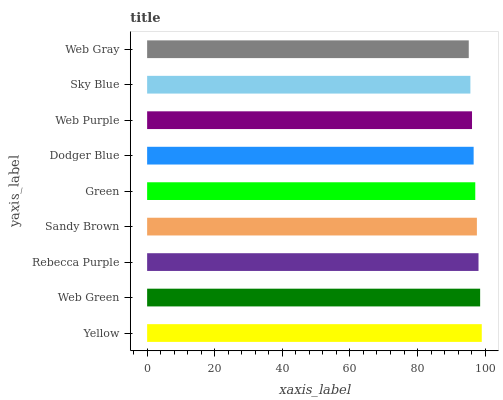Is Web Gray the minimum?
Answer yes or no. Yes. Is Yellow the maximum?
Answer yes or no. Yes. Is Web Green the minimum?
Answer yes or no. No. Is Web Green the maximum?
Answer yes or no. No. Is Yellow greater than Web Green?
Answer yes or no. Yes. Is Web Green less than Yellow?
Answer yes or no. Yes. Is Web Green greater than Yellow?
Answer yes or no. No. Is Yellow less than Web Green?
Answer yes or no. No. Is Green the high median?
Answer yes or no. Yes. Is Green the low median?
Answer yes or no. Yes. Is Sky Blue the high median?
Answer yes or no. No. Is Web Green the low median?
Answer yes or no. No. 